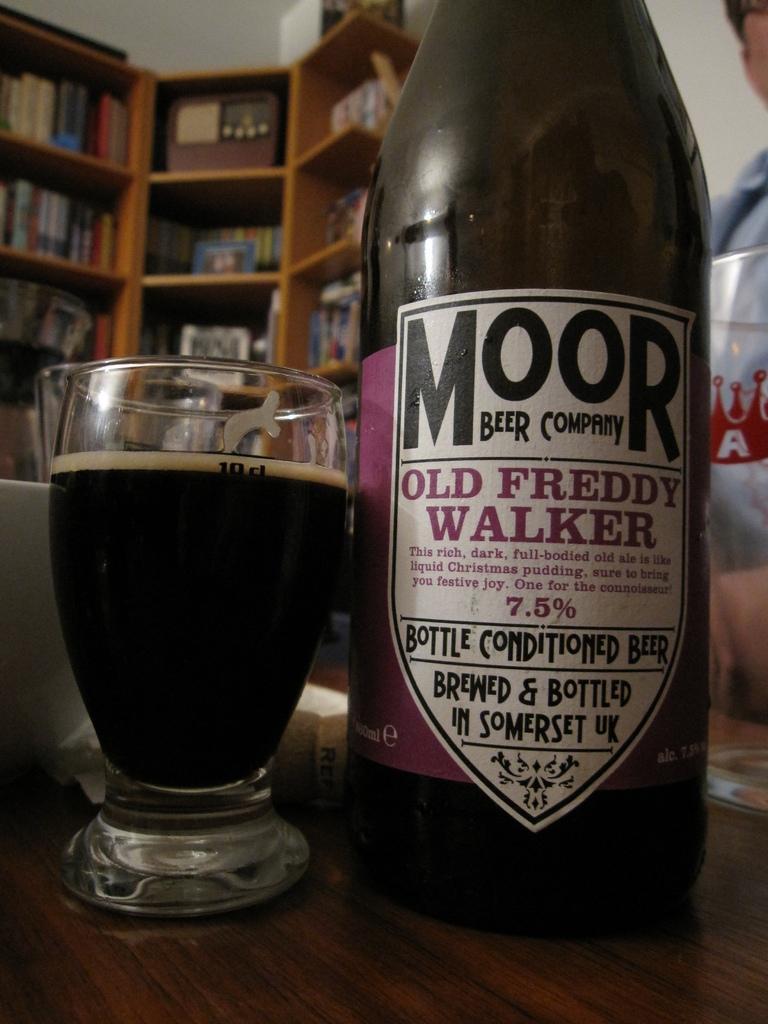In one or two sentences, can you explain what this image depicts? In this picture we can see one bottle and glass on the table, back side there is a bookshelf. 